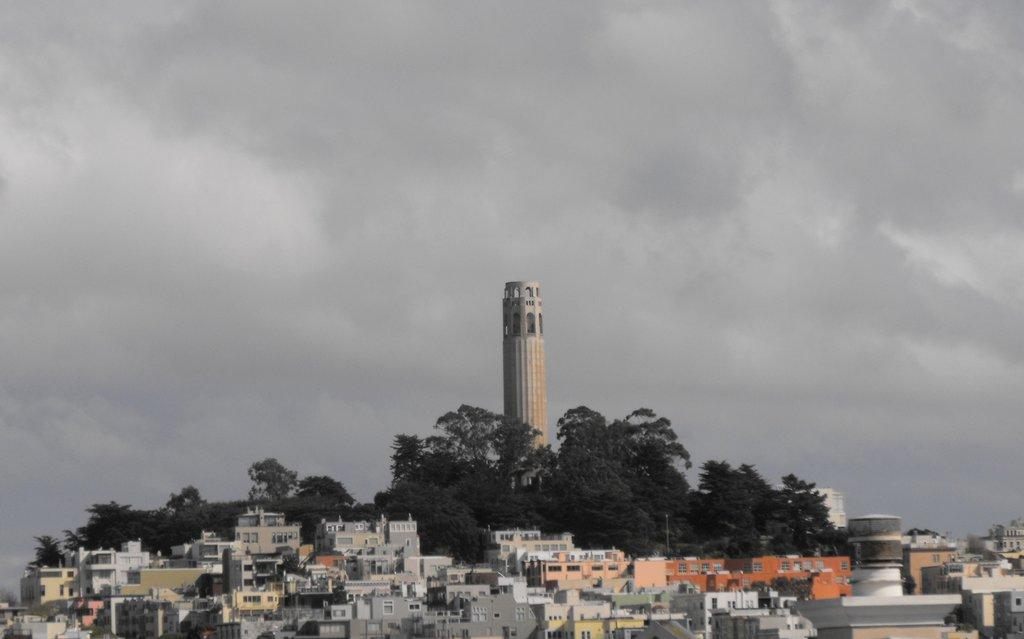What type of structures can be seen in the image? There are many buildings in the image. What other natural elements are present in the image? There are trees in the image. Can you describe the tallest building in the image? There is a tower building in the background. What is visible above the buildings and trees in the image? The sky is visible in the image. How would you describe the weather based on the appearance of the sky? The sky appears to be cloudy in the image. What type of tool is the porter using to fix the tower building in the image? There is no porter or tool visible in the image, and the tower building does not appear to be undergoing any repairs. 